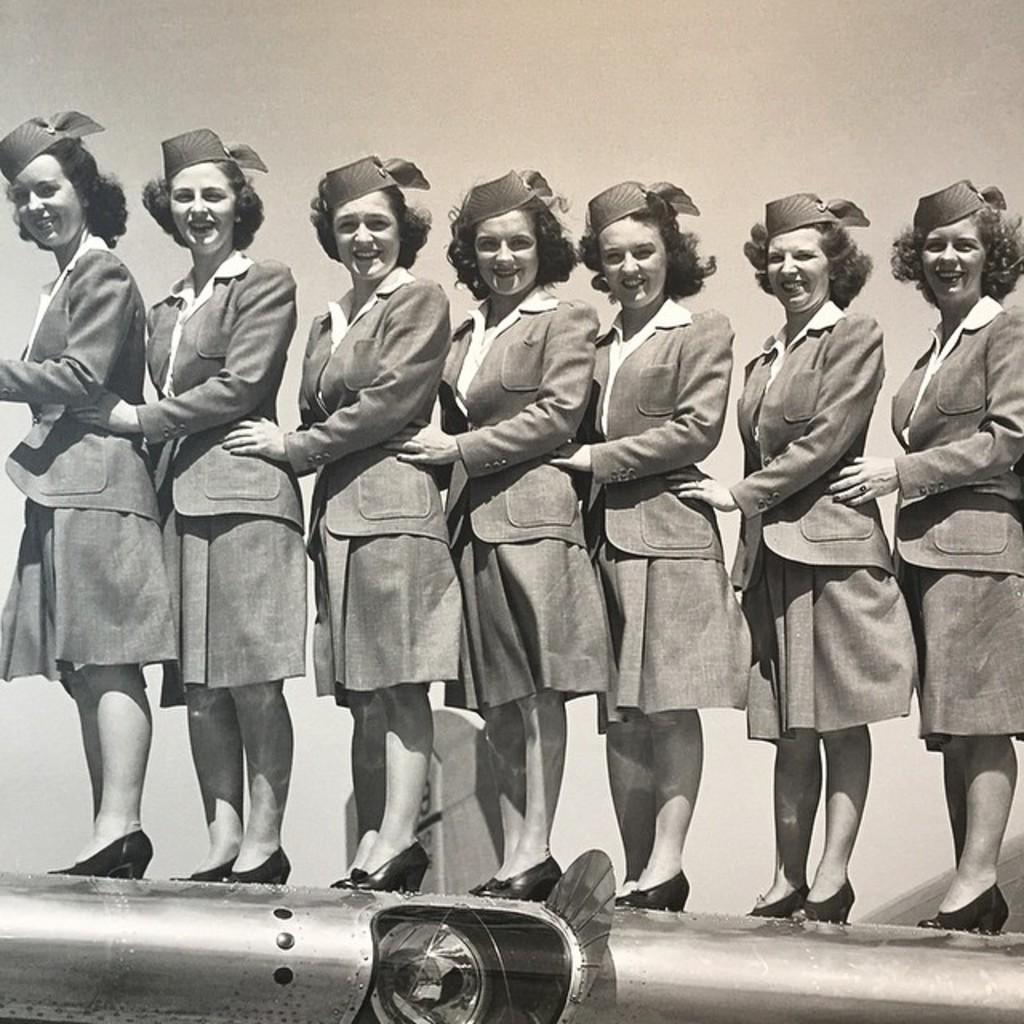Describe this image in one or two sentences. In this image there is a group of people in the uniform standing on the vehicle. 